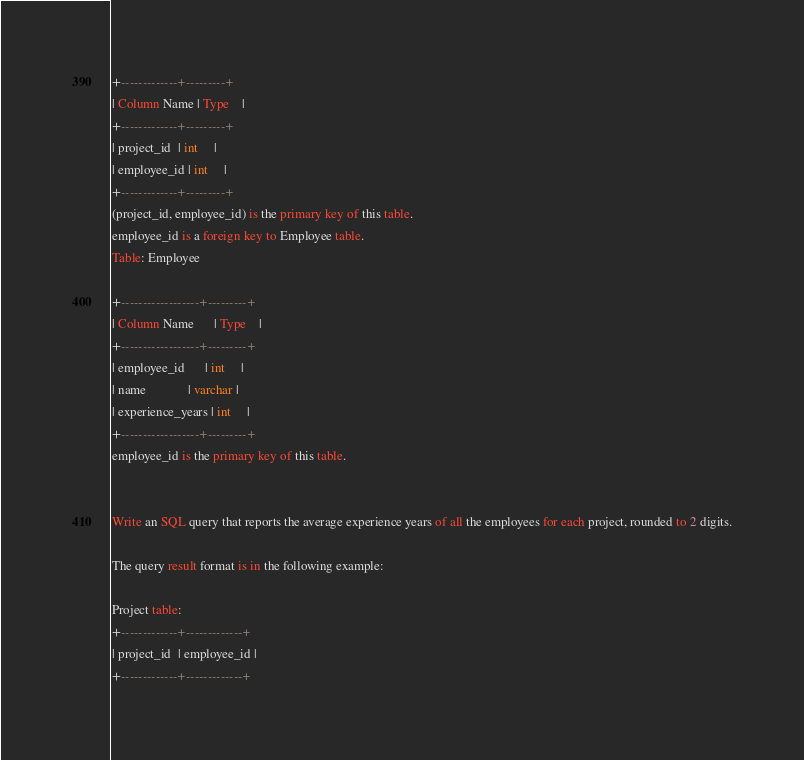Convert code to text. <code><loc_0><loc_0><loc_500><loc_500><_SQL_>
+-------------+---------+
| Column Name | Type    |
+-------------+---------+
| project_id  | int     |
| employee_id | int     |
+-------------+---------+
(project_id, employee_id) is the primary key of this table.
employee_id is a foreign key to Employee table.
Table: Employee

+------------------+---------+
| Column Name      | Type    |
+------------------+---------+
| employee_id      | int     |
| name             | varchar |
| experience_years | int     |
+------------------+---------+
employee_id is the primary key of this table.
 

Write an SQL query that reports the average experience years of all the employees for each project, rounded to 2 digits.

The query result format is in the following example:

Project table:
+-------------+-------------+
| project_id  | employee_id |
+-------------+-------------+</code> 